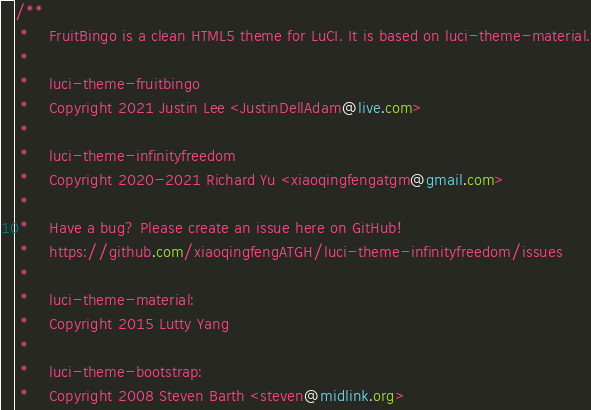<code> <loc_0><loc_0><loc_500><loc_500><_CSS_>/**
 *    FruitBingo is a clean HTML5 theme for LuCI. It is based on luci-theme-material.
 *
 *    luci-theme-fruitbingo
 *    Copyright 2021 Justin Lee <JustinDellAdam@live.com>
 *
 *    luci-theme-infinityfreedom
 *    Copyright 2020-2021 Richard Yu <xiaoqingfengatgm@gmail.com>
 *
 *    Have a bug? Please create an issue here on GitHub!
 *    https://github.com/xiaoqingfengATGH/luci-theme-infinityfreedom/issues
 *
 *    luci-theme-material:
 *    Copyright 2015 Lutty Yang
 *
 *    luci-theme-bootstrap:
 *    Copyright 2008 Steven Barth <steven@midlink.org></code> 